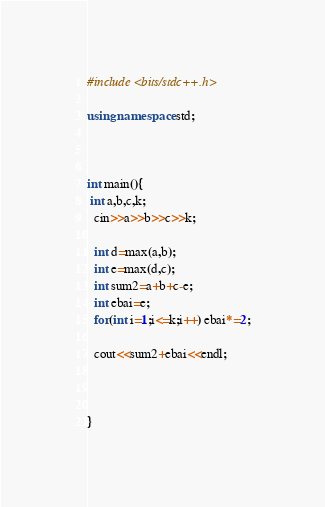Convert code to text. <code><loc_0><loc_0><loc_500><loc_500><_C++_>#include <bits/stdc++.h>

using namespace std;



int main(){
 int a,b,c,k;
  cin>>a>>b>>c>>k;
  
  int d=max(a,b);
  int e=max(d,c);
  int sum2=a+b+c-e;
  int ebai=e;
  for(int i=1;i<=k;i++) ebai*=2;
  
  cout<<sum2+ebai<<endl;
   
  
  
}
</code> 